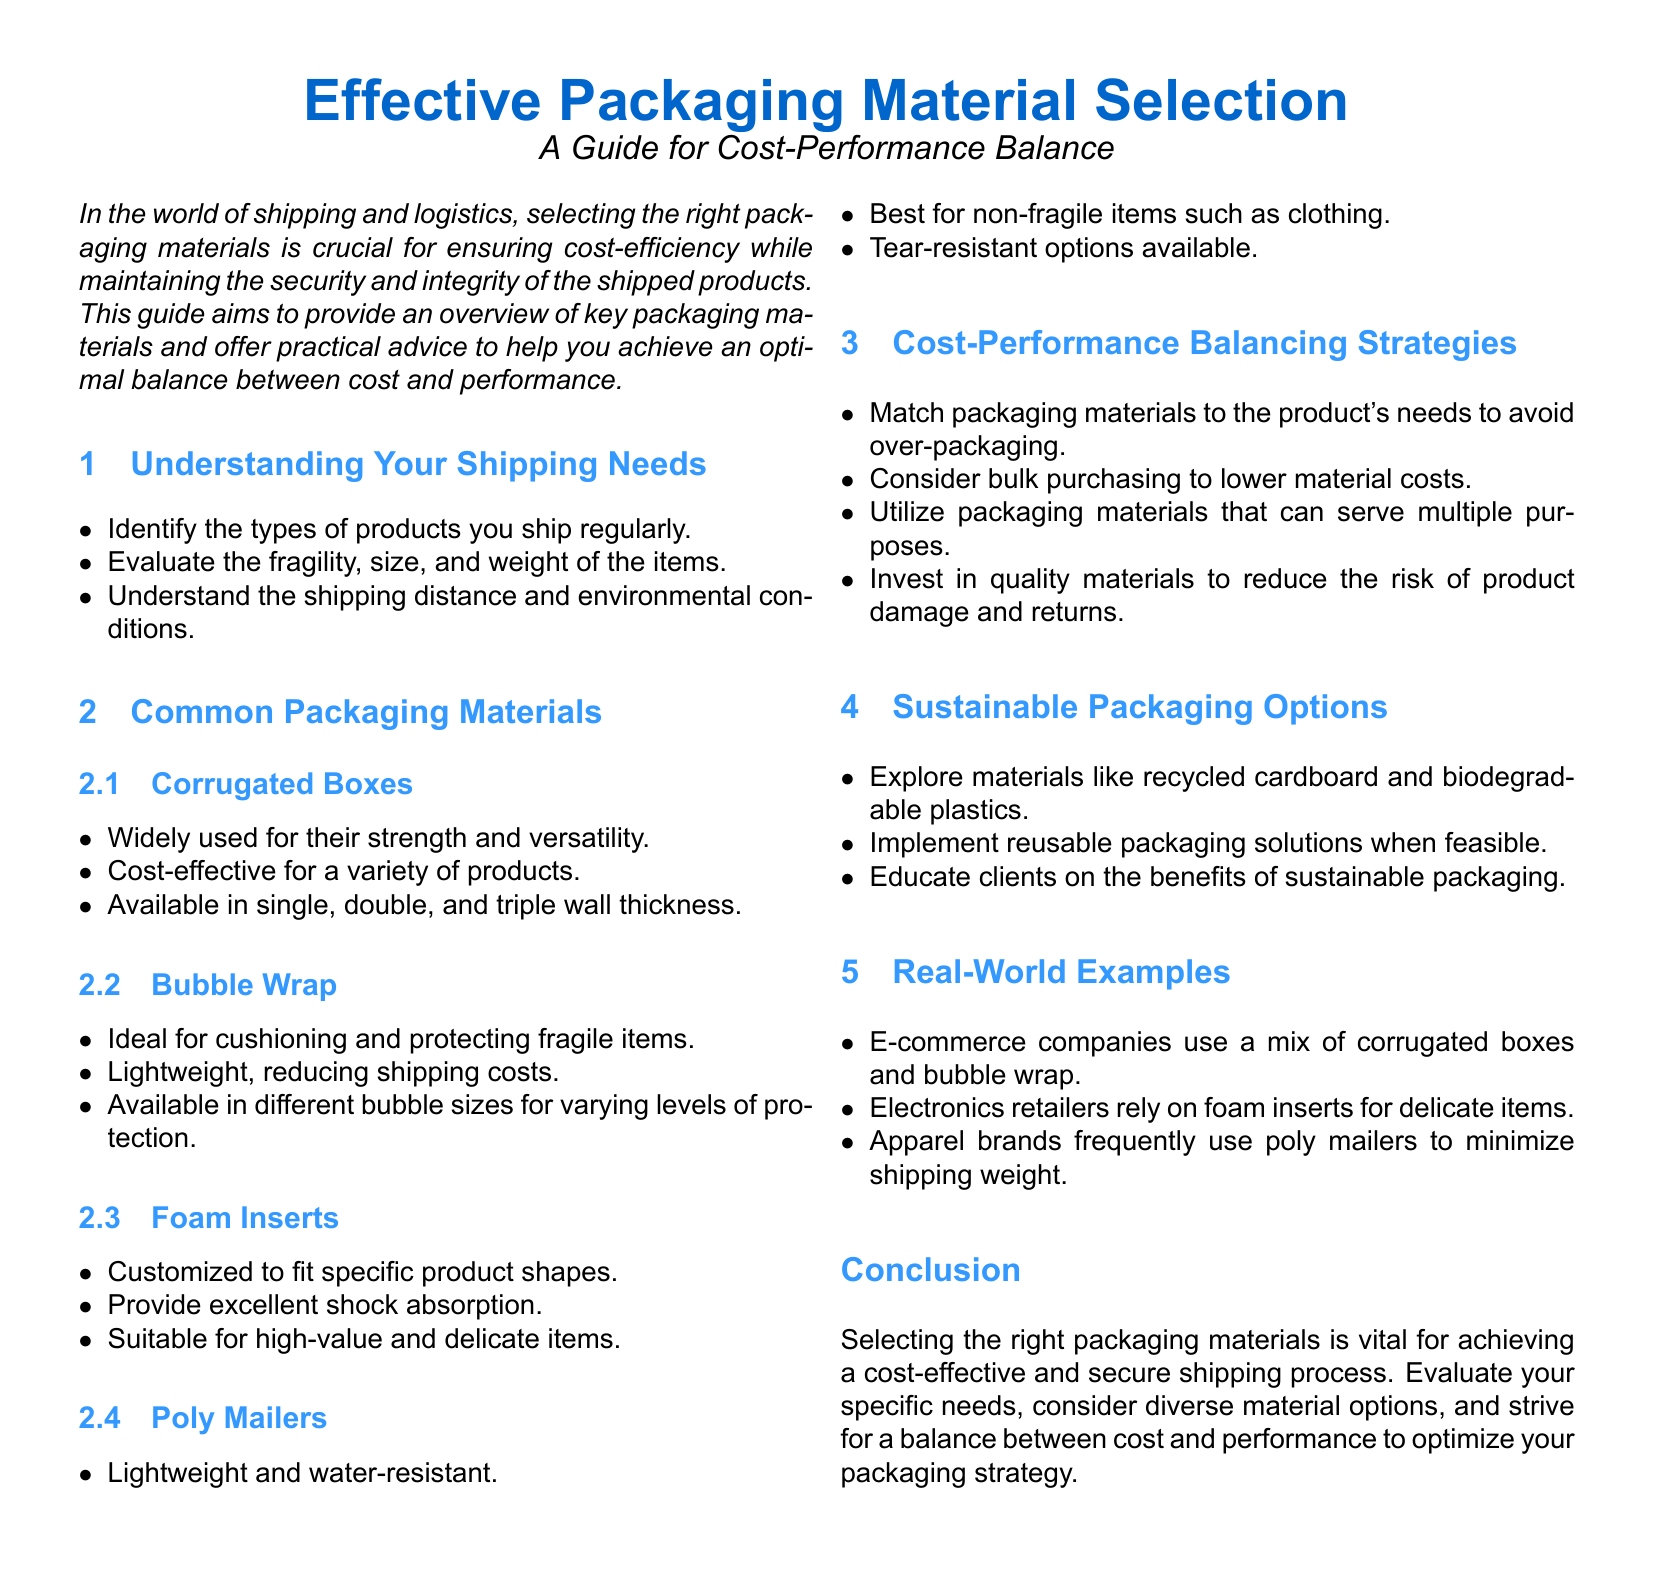What is the main focus of the guide? The main focus of the guide is to provide an overview of key packaging materials and offer practical advice for achieving an optimal balance between cost and performance.
Answer: Cost-performance balance What type of boxes are highlighted for their strength and versatility? The document mentions that corrugated boxes are widely used for their strength and versatility.
Answer: Corrugated Boxes What is suggested as ideal for cushioning fragile items? The guide states that bubble wrap is ideal for cushioning and protecting fragile items.
Answer: Bubble Wrap Which packaging material is described as lightweight and water-resistant? The document notes that poly mailers are lightweight and water-resistant.
Answer: Poly Mailers What strategy can help lower material costs? The guide suggests considering bulk purchasing to lower material costs.
Answer: Bulk purchasing What is one sustainable packaging option? The document mentions exploring materials like recycled cardboard as a sustainable packaging option.
Answer: Recycled cardboard What are foam inserts suitable for according to the guide? Foam inserts are described as suitable for high-value and delicate items.
Answer: High-value and delicate items Which companies are provided as real-world examples in the guide? E-commerce companies, electronics retailers, and apparel brands are given as examples.
Answer: E-commerce companies, electronics retailers, apparel brands What does the conclusion emphasize about packaging materials? The conclusion emphasizes that selecting the right packaging materials is vital for achieving a cost-effective and secure shipping process.
Answer: Vital for cost-effective and secure shipping process 